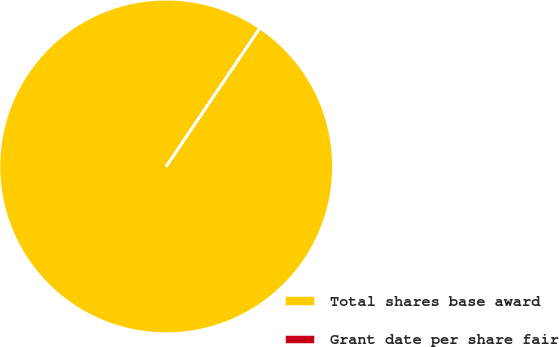Convert chart. <chart><loc_0><loc_0><loc_500><loc_500><pie_chart><fcel>Total shares base award<fcel>Grant date per share fair<nl><fcel>99.99%<fcel>0.01%<nl></chart> 